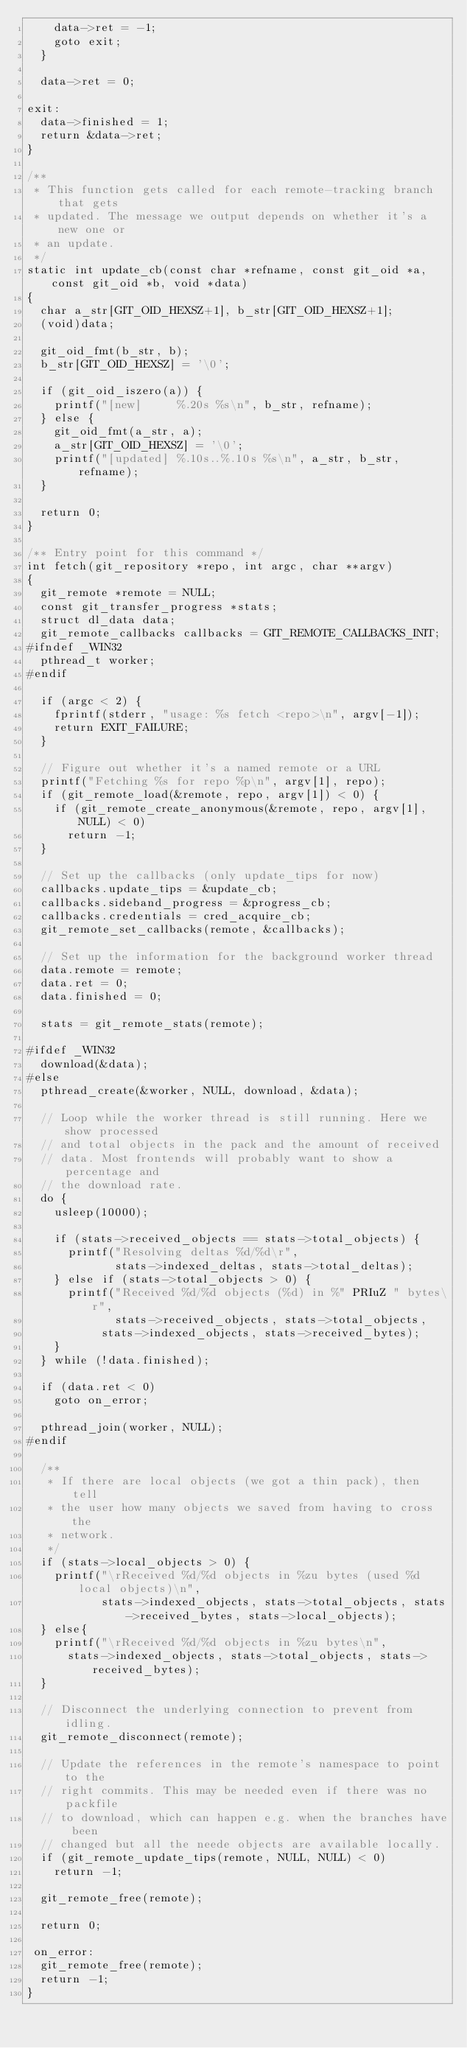<code> <loc_0><loc_0><loc_500><loc_500><_C_>		data->ret = -1;
		goto exit;
	}

	data->ret = 0;

exit:
	data->finished = 1;
	return &data->ret;
}

/**
 * This function gets called for each remote-tracking branch that gets
 * updated. The message we output depends on whether it's a new one or
 * an update.
 */
static int update_cb(const char *refname, const git_oid *a, const git_oid *b, void *data)
{
	char a_str[GIT_OID_HEXSZ+1], b_str[GIT_OID_HEXSZ+1];
	(void)data;

	git_oid_fmt(b_str, b);
	b_str[GIT_OID_HEXSZ] = '\0';

	if (git_oid_iszero(a)) {
		printf("[new]     %.20s %s\n", b_str, refname);
	} else {
		git_oid_fmt(a_str, a);
		a_str[GIT_OID_HEXSZ] = '\0';
		printf("[updated] %.10s..%.10s %s\n", a_str, b_str, refname);
	}

	return 0;
}

/** Entry point for this command */
int fetch(git_repository *repo, int argc, char **argv)
{
	git_remote *remote = NULL;
	const git_transfer_progress *stats;
	struct dl_data data;
	git_remote_callbacks callbacks = GIT_REMOTE_CALLBACKS_INIT;
#ifndef _WIN32
	pthread_t worker;
#endif

	if (argc < 2) {
		fprintf(stderr, "usage: %s fetch <repo>\n", argv[-1]);
		return EXIT_FAILURE;
	}

	// Figure out whether it's a named remote or a URL
	printf("Fetching %s for repo %p\n", argv[1], repo);
	if (git_remote_load(&remote, repo, argv[1]) < 0) {
		if (git_remote_create_anonymous(&remote, repo, argv[1], NULL) < 0)
			return -1;
	}

	// Set up the callbacks (only update_tips for now)
	callbacks.update_tips = &update_cb;
	callbacks.sideband_progress = &progress_cb;
	callbacks.credentials = cred_acquire_cb;
	git_remote_set_callbacks(remote, &callbacks);

	// Set up the information for the background worker thread
	data.remote = remote;
	data.ret = 0;
	data.finished = 0;

	stats = git_remote_stats(remote);

#ifdef _WIN32
	download(&data);
#else
	pthread_create(&worker, NULL, download, &data);

	// Loop while the worker thread is still running. Here we show processed
	// and total objects in the pack and the amount of received
	// data. Most frontends will probably want to show a percentage and
	// the download rate.
	do {
		usleep(10000);

		if (stats->received_objects == stats->total_objects) {
			printf("Resolving deltas %d/%d\r",
			       stats->indexed_deltas, stats->total_deltas);
		} else if (stats->total_objects > 0) {
			printf("Received %d/%d objects (%d) in %" PRIuZ " bytes\r",
			       stats->received_objects, stats->total_objects,
				   stats->indexed_objects, stats->received_bytes);
		}
	} while (!data.finished);

	if (data.ret < 0)
		goto on_error;

	pthread_join(worker, NULL);
#endif

	/**
	 * If there are local objects (we got a thin pack), then tell
	 * the user how many objects we saved from having to cross the
	 * network.
	 */
	if (stats->local_objects > 0) {
		printf("\rReceived %d/%d objects in %zu bytes (used %d local objects)\n",
		       stats->indexed_objects, stats->total_objects, stats->received_bytes, stats->local_objects);
	} else{
		printf("\rReceived %d/%d objects in %zu bytes\n",
			stats->indexed_objects, stats->total_objects, stats->received_bytes);
	}

	// Disconnect the underlying connection to prevent from idling.
	git_remote_disconnect(remote);

	// Update the references in the remote's namespace to point to the
	// right commits. This may be needed even if there was no packfile
	// to download, which can happen e.g. when the branches have been
	// changed but all the neede objects are available locally.
	if (git_remote_update_tips(remote, NULL, NULL) < 0)
		return -1;

	git_remote_free(remote);

	return 0;

 on_error:
	git_remote_free(remote);
	return -1;
}
</code> 